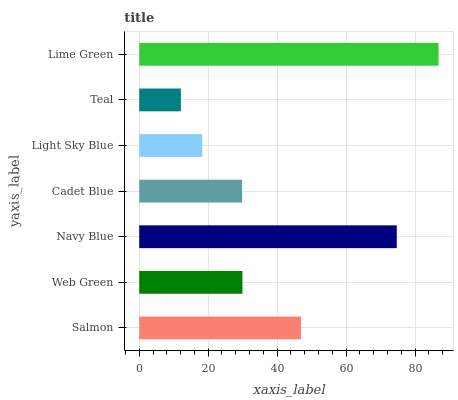Is Teal the minimum?
Answer yes or no. Yes. Is Lime Green the maximum?
Answer yes or no. Yes. Is Web Green the minimum?
Answer yes or no. No. Is Web Green the maximum?
Answer yes or no. No. Is Salmon greater than Web Green?
Answer yes or no. Yes. Is Web Green less than Salmon?
Answer yes or no. Yes. Is Web Green greater than Salmon?
Answer yes or no. No. Is Salmon less than Web Green?
Answer yes or no. No. Is Web Green the high median?
Answer yes or no. Yes. Is Web Green the low median?
Answer yes or no. Yes. Is Light Sky Blue the high median?
Answer yes or no. No. Is Navy Blue the low median?
Answer yes or no. No. 